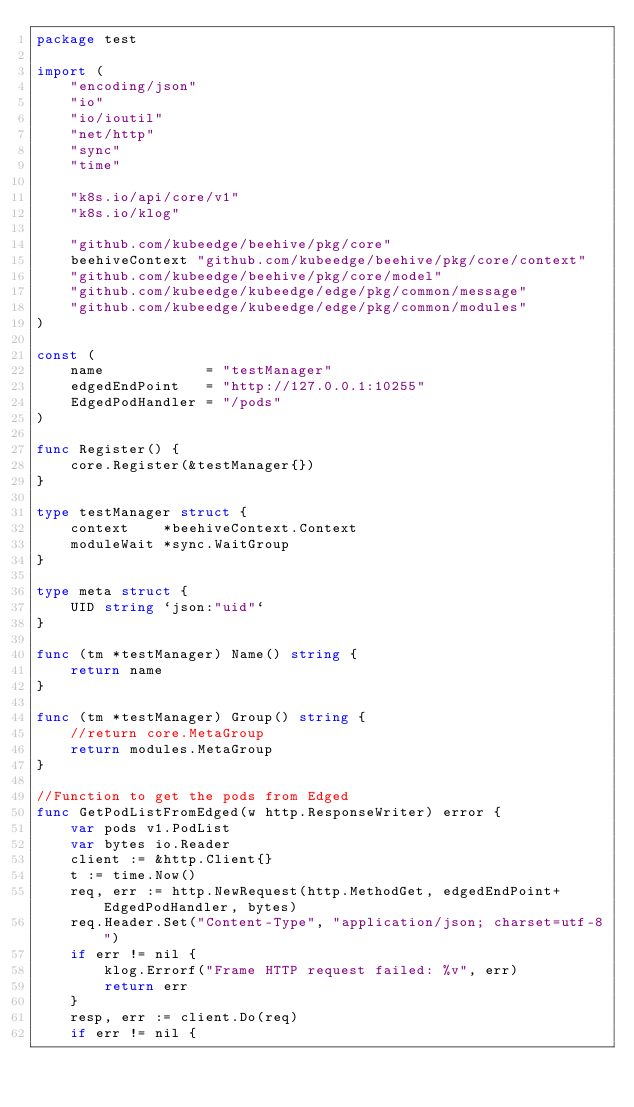Convert code to text. <code><loc_0><loc_0><loc_500><loc_500><_Go_>package test

import (
	"encoding/json"
	"io"
	"io/ioutil"
	"net/http"
	"sync"
	"time"

	"k8s.io/api/core/v1"
	"k8s.io/klog"

	"github.com/kubeedge/beehive/pkg/core"
	beehiveContext "github.com/kubeedge/beehive/pkg/core/context"
	"github.com/kubeedge/beehive/pkg/core/model"
	"github.com/kubeedge/kubeedge/edge/pkg/common/message"
	"github.com/kubeedge/kubeedge/edge/pkg/common/modules"
)

const (
	name            = "testManager"
	edgedEndPoint   = "http://127.0.0.1:10255"
	EdgedPodHandler = "/pods"
)

func Register() {
	core.Register(&testManager{})
}

type testManager struct {
	context    *beehiveContext.Context
	moduleWait *sync.WaitGroup
}

type meta struct {
	UID string `json:"uid"`
}

func (tm *testManager) Name() string {
	return name
}

func (tm *testManager) Group() string {
	//return core.MetaGroup
	return modules.MetaGroup
}

//Function to get the pods from Edged
func GetPodListFromEdged(w http.ResponseWriter) error {
	var pods v1.PodList
	var bytes io.Reader
	client := &http.Client{}
	t := time.Now()
	req, err := http.NewRequest(http.MethodGet, edgedEndPoint+EdgedPodHandler, bytes)
	req.Header.Set("Content-Type", "application/json; charset=utf-8")
	if err != nil {
		klog.Errorf("Frame HTTP request failed: %v", err)
		return err
	}
	resp, err := client.Do(req)
	if err != nil {</code> 